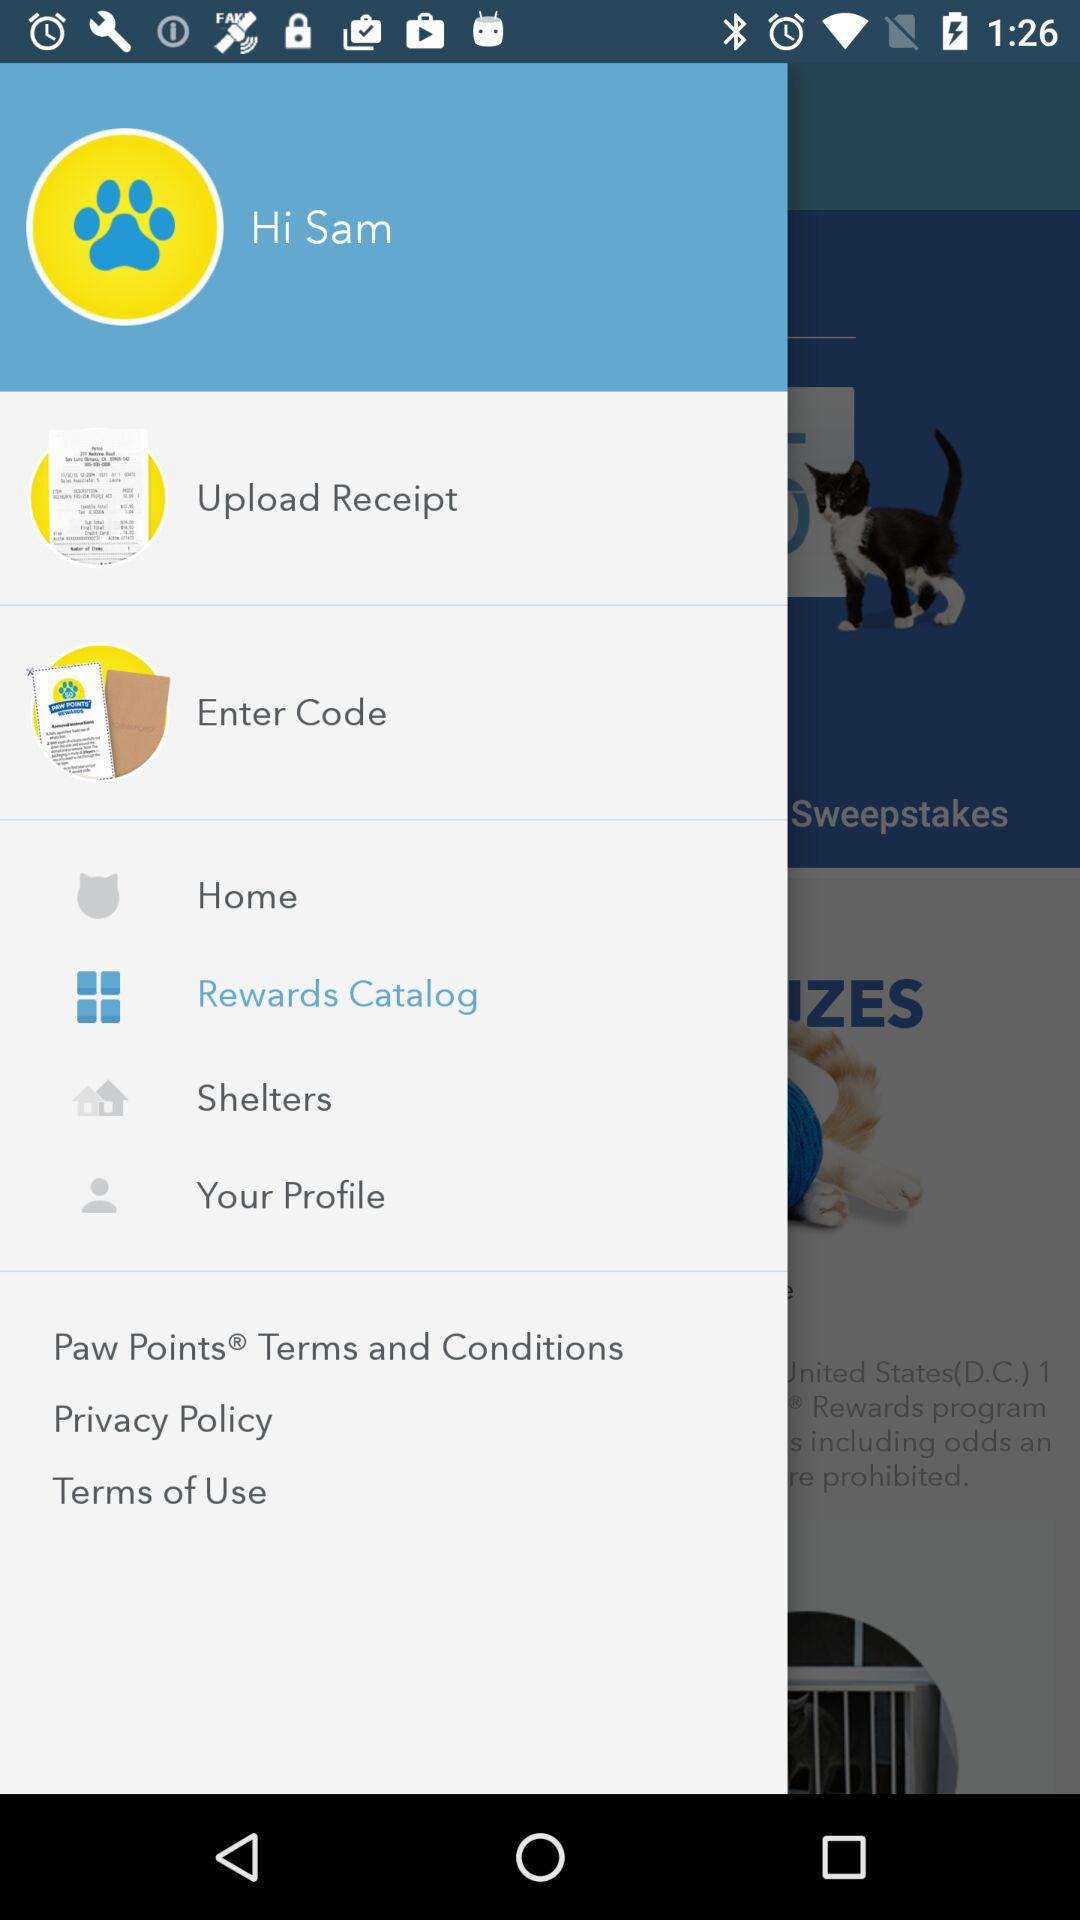Which item has been selected? The item that has been selected is "Rewards Catalog". 